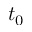Convert formula to latex. <formula><loc_0><loc_0><loc_500><loc_500>t _ { 0 }</formula> 